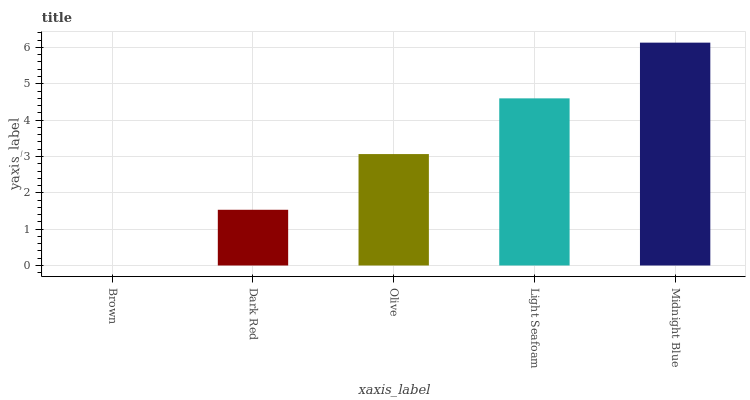Is Brown the minimum?
Answer yes or no. Yes. Is Midnight Blue the maximum?
Answer yes or no. Yes. Is Dark Red the minimum?
Answer yes or no. No. Is Dark Red the maximum?
Answer yes or no. No. Is Dark Red greater than Brown?
Answer yes or no. Yes. Is Brown less than Dark Red?
Answer yes or no. Yes. Is Brown greater than Dark Red?
Answer yes or no. No. Is Dark Red less than Brown?
Answer yes or no. No. Is Olive the high median?
Answer yes or no. Yes. Is Olive the low median?
Answer yes or no. Yes. Is Light Seafoam the high median?
Answer yes or no. No. Is Midnight Blue the low median?
Answer yes or no. No. 